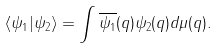<formula> <loc_0><loc_0><loc_500><loc_500>\langle \psi _ { 1 } | \psi _ { 2 } \rangle = \int \overline { \psi _ { 1 } } ( q ) \psi _ { 2 } ( q ) d \mu ( q ) .</formula> 